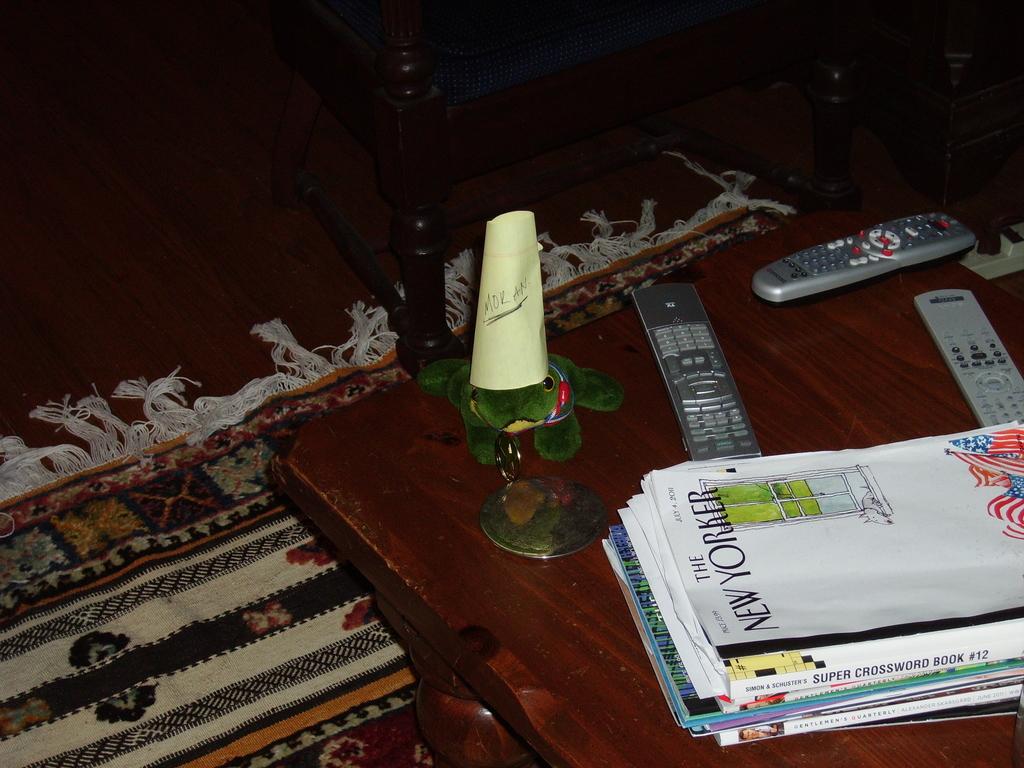Are they comic books ?
Provide a short and direct response. No. What is the title of the top magazine?
Your answer should be compact. New yorker. 